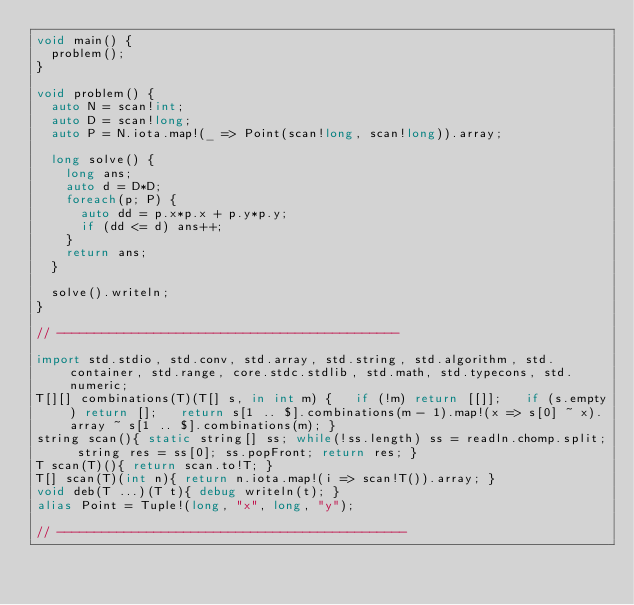<code> <loc_0><loc_0><loc_500><loc_500><_D_>void main() {
  problem();
}

void problem() {
  auto N = scan!int;
  auto D = scan!long;
  auto P = N.iota.map!(_ => Point(scan!long, scan!long)).array;

  long solve() {
    long ans;
    auto d = D*D;
    foreach(p; P) {
      auto dd = p.x*p.x + p.y*p.y;
      if (dd <= d) ans++;
    }
    return ans;
  }

  solve().writeln;
}

// ----------------------------------------------

import std.stdio, std.conv, std.array, std.string, std.algorithm, std.container, std.range, core.stdc.stdlib, std.math, std.typecons, std.numeric;
T[][] combinations(T)(T[] s, in int m) {   if (!m) return [[]];   if (s.empty) return [];   return s[1 .. $].combinations(m - 1).map!(x => s[0] ~ x).array ~ s[1 .. $].combinations(m); }
string scan(){ static string[] ss; while(!ss.length) ss = readln.chomp.split; string res = ss[0]; ss.popFront; return res; }
T scan(T)(){ return scan.to!T; }
T[] scan(T)(int n){ return n.iota.map!(i => scan!T()).array; }
void deb(T ...)(T t){ debug writeln(t); }
alias Point = Tuple!(long, "x", long, "y");

// -----------------------------------------------
</code> 